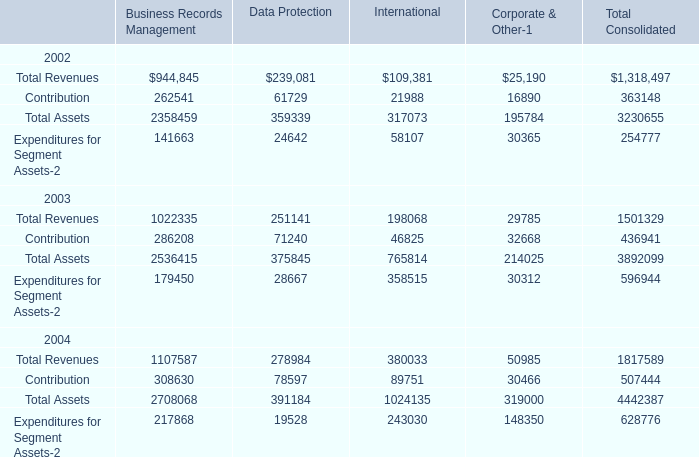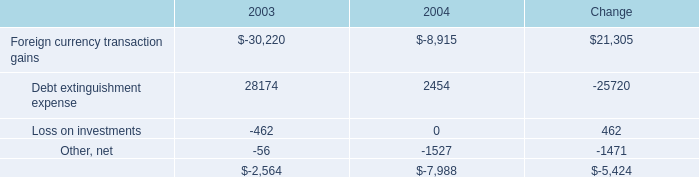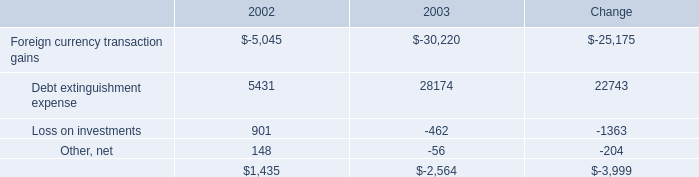what's the total amount of Contribution of Data Protection, Foreign currency transaction gains of 2003, and total of 2003 ? 
Computations: ((61729.0 + 30220.0) + 2564.0)
Answer: 94513.0. 